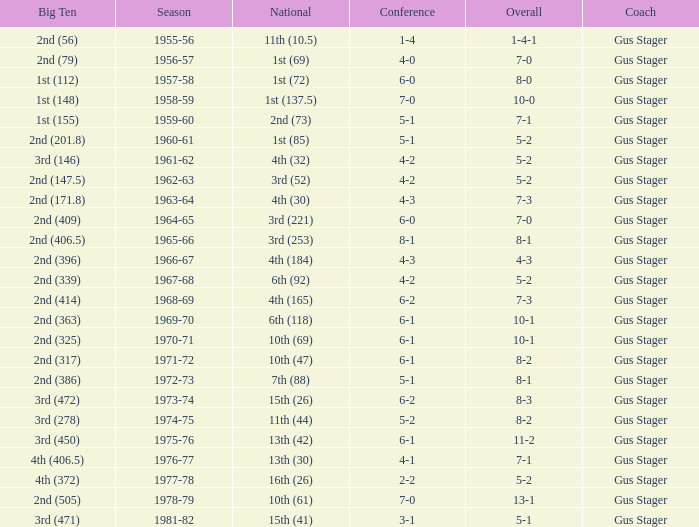What is the Coach with a Big Ten that is 2nd (79)? Gus Stager. 